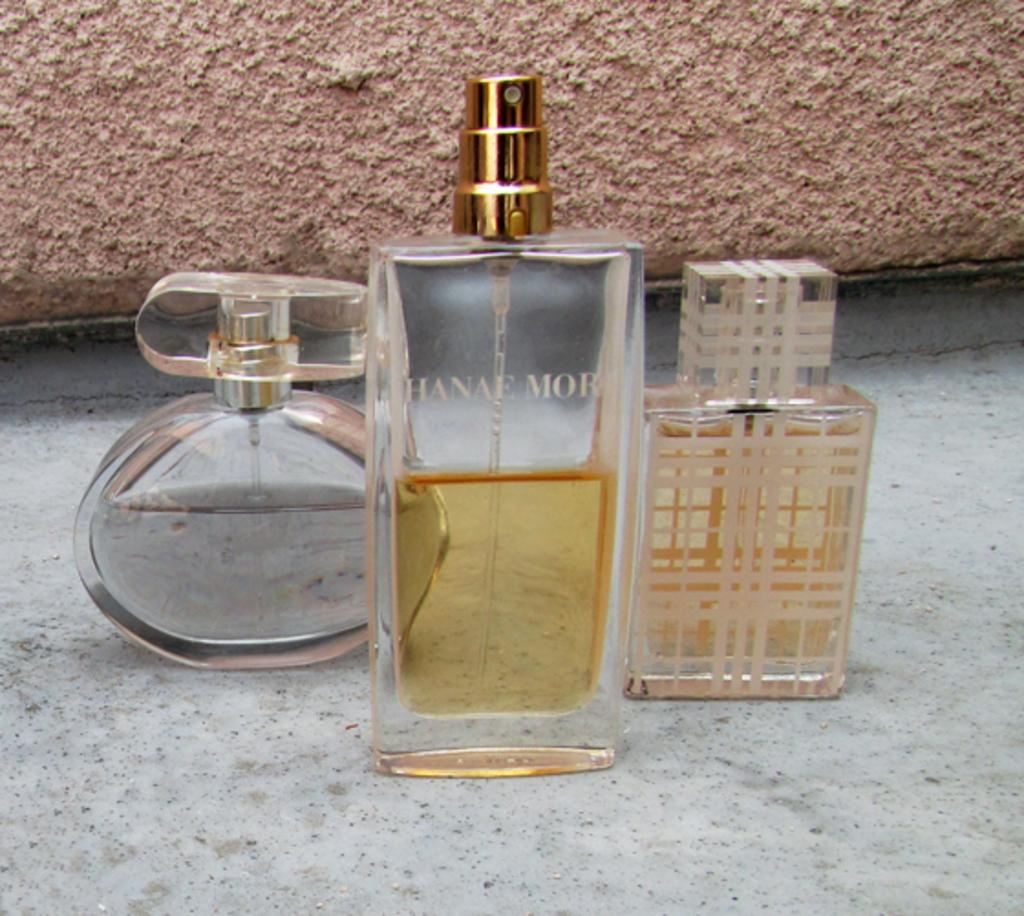<image>
Write a terse but informative summary of the picture. Three bottles of perfume sit on the shelf with a half bottle of Hanae Mor in the middle. 